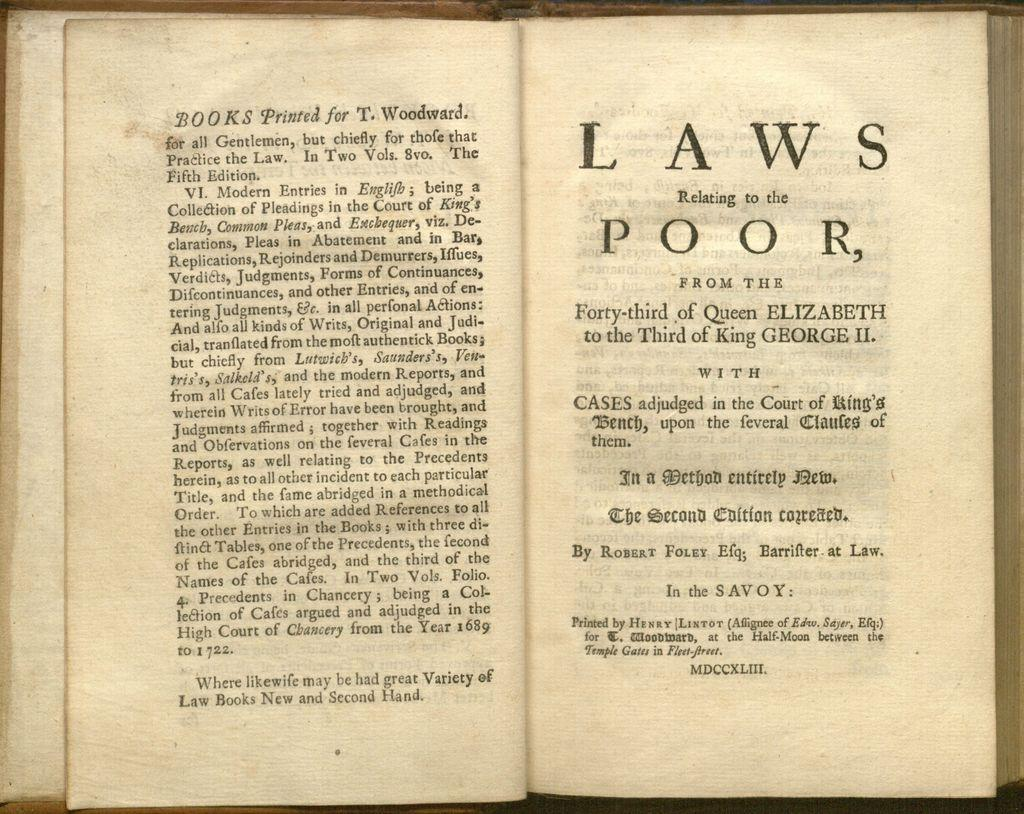<image>
Share a concise interpretation of the image provided. A book with thin, almost transparent pages is titled Laws Relating to the Poor. 